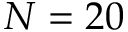Convert formula to latex. <formula><loc_0><loc_0><loc_500><loc_500>N = 2 0</formula> 